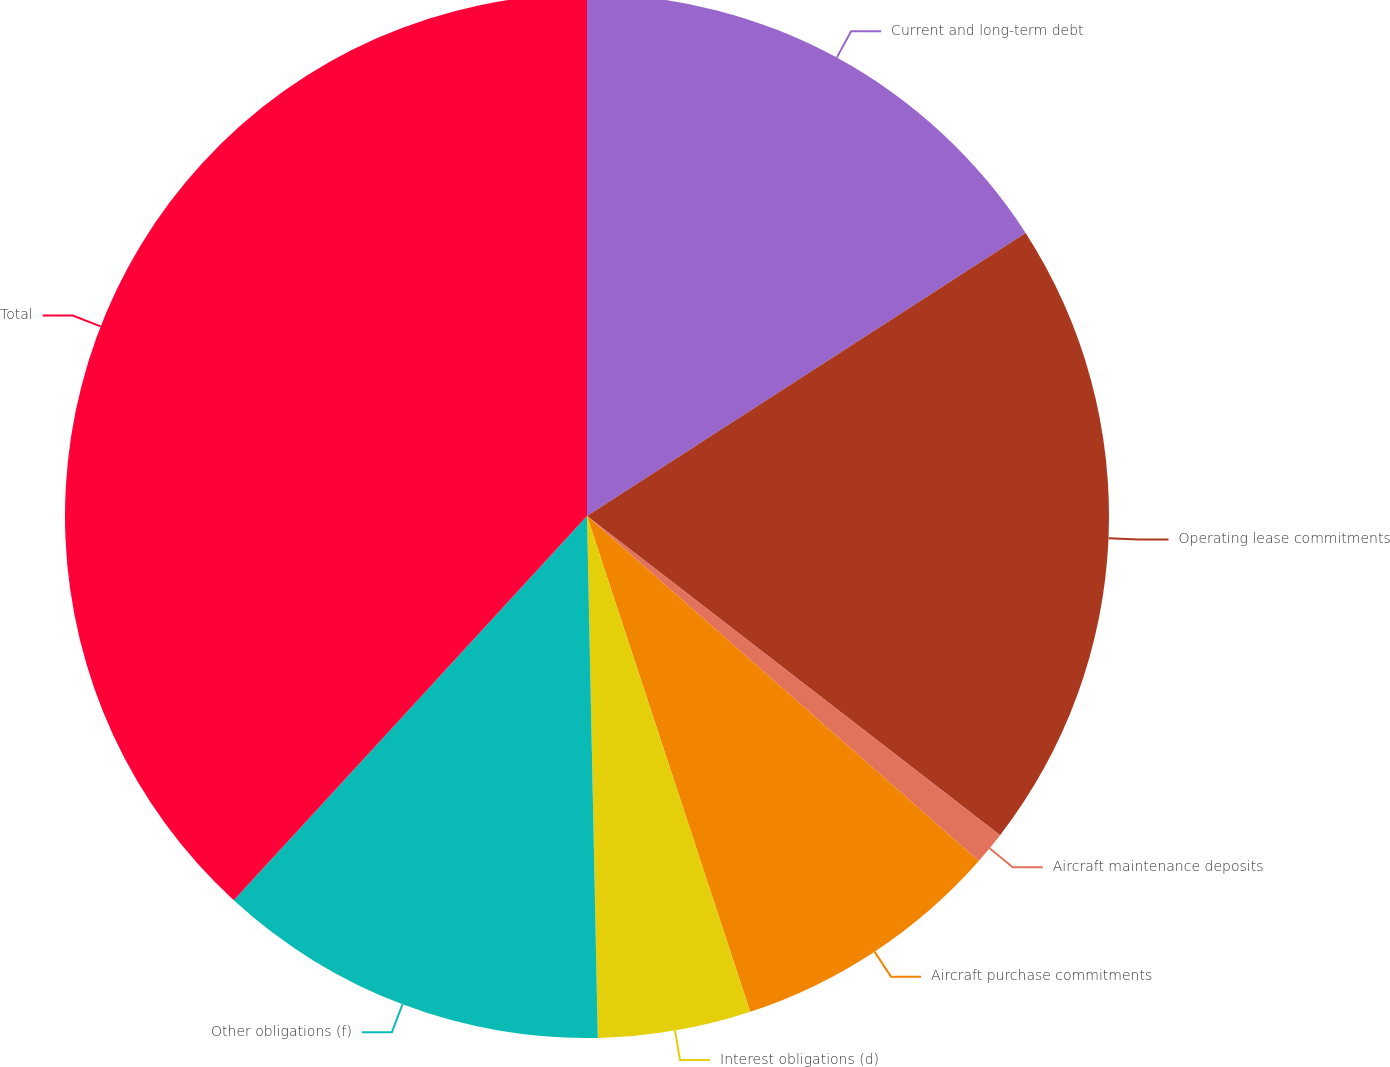Convert chart. <chart><loc_0><loc_0><loc_500><loc_500><pie_chart><fcel>Current and long-term debt<fcel>Operating lease commitments<fcel>Aircraft maintenance deposits<fcel>Aircraft purchase commitments<fcel>Interest obligations (d)<fcel>Other obligations (f)<fcel>Total<nl><fcel>15.88%<fcel>19.59%<fcel>1.02%<fcel>8.45%<fcel>4.73%<fcel>12.16%<fcel>38.17%<nl></chart> 